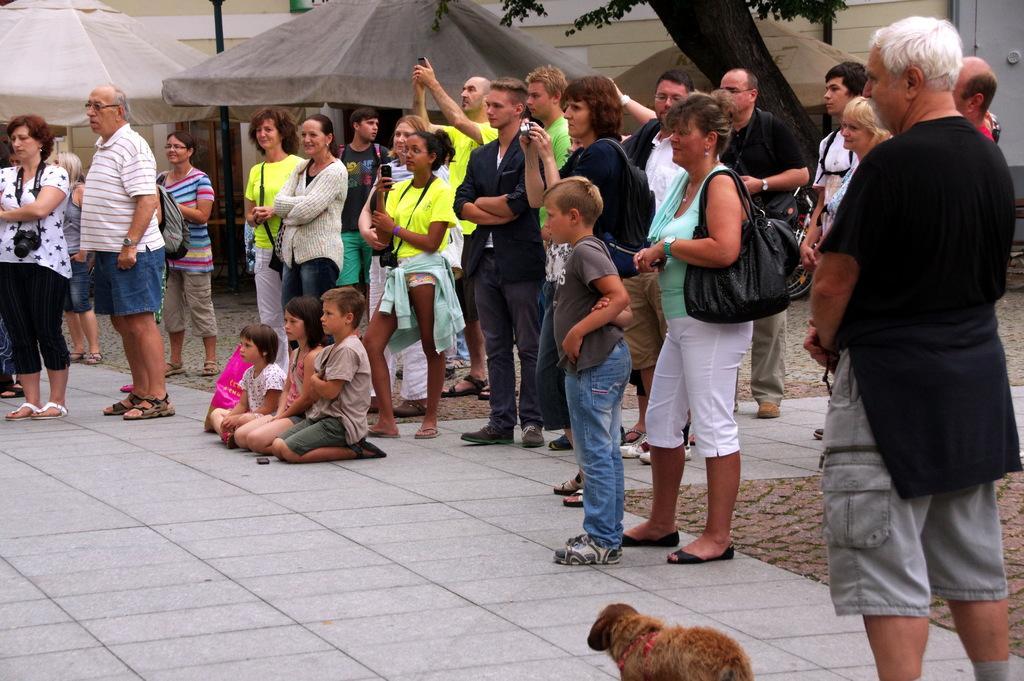Could you give a brief overview of what you see in this image? In the image we can see persons on the floor. At the bottom there is a dog. In the background there is a tents, pole, building and tree. 